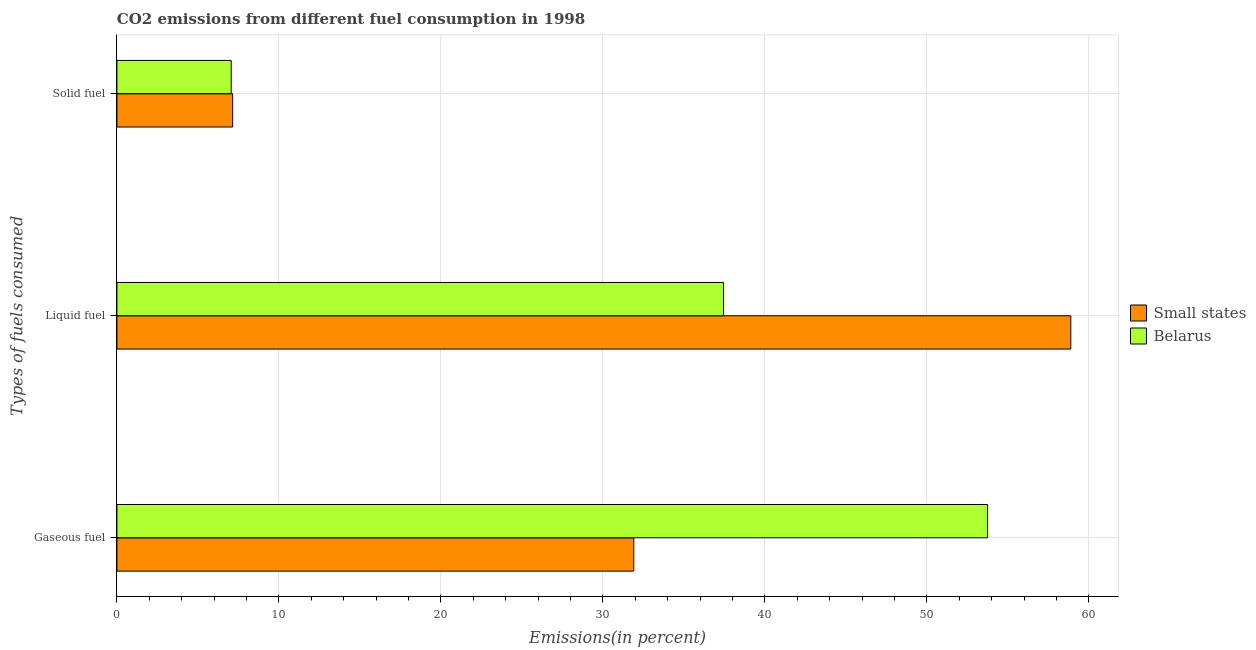Are the number of bars per tick equal to the number of legend labels?
Offer a terse response. Yes. How many bars are there on the 2nd tick from the top?
Your answer should be compact. 2. What is the label of the 3rd group of bars from the top?
Offer a terse response. Gaseous fuel. What is the percentage of solid fuel emission in Small states?
Ensure brevity in your answer.  7.14. Across all countries, what is the maximum percentage of solid fuel emission?
Offer a very short reply. 7.14. Across all countries, what is the minimum percentage of gaseous fuel emission?
Provide a short and direct response. 31.9. In which country was the percentage of liquid fuel emission maximum?
Your response must be concise. Small states. In which country was the percentage of gaseous fuel emission minimum?
Give a very brief answer. Small states. What is the total percentage of solid fuel emission in the graph?
Offer a very short reply. 14.2. What is the difference between the percentage of solid fuel emission in Small states and that in Belarus?
Your response must be concise. 0.09. What is the difference between the percentage of liquid fuel emission in Small states and the percentage of solid fuel emission in Belarus?
Your answer should be very brief. 51.82. What is the average percentage of gaseous fuel emission per country?
Provide a succinct answer. 42.82. What is the difference between the percentage of solid fuel emission and percentage of gaseous fuel emission in Small states?
Make the answer very short. -24.76. What is the ratio of the percentage of liquid fuel emission in Small states to that in Belarus?
Keep it short and to the point. 1.57. Is the difference between the percentage of liquid fuel emission in Belarus and Small states greater than the difference between the percentage of solid fuel emission in Belarus and Small states?
Offer a terse response. No. What is the difference between the highest and the second highest percentage of gaseous fuel emission?
Your answer should be compact. 21.84. What is the difference between the highest and the lowest percentage of liquid fuel emission?
Your answer should be very brief. 21.44. Is the sum of the percentage of liquid fuel emission in Belarus and Small states greater than the maximum percentage of gaseous fuel emission across all countries?
Provide a succinct answer. Yes. What does the 2nd bar from the top in Liquid fuel represents?
Give a very brief answer. Small states. What does the 2nd bar from the bottom in Gaseous fuel represents?
Offer a very short reply. Belarus. Are all the bars in the graph horizontal?
Your answer should be very brief. Yes. How many countries are there in the graph?
Your answer should be compact. 2. What is the difference between two consecutive major ticks on the X-axis?
Your answer should be very brief. 10. Are the values on the major ticks of X-axis written in scientific E-notation?
Ensure brevity in your answer.  No. Does the graph contain any zero values?
Your answer should be very brief. No. Does the graph contain grids?
Make the answer very short. Yes. How many legend labels are there?
Offer a very short reply. 2. What is the title of the graph?
Give a very brief answer. CO2 emissions from different fuel consumption in 1998. Does "United Arab Emirates" appear as one of the legend labels in the graph?
Your response must be concise. No. What is the label or title of the X-axis?
Provide a short and direct response. Emissions(in percent). What is the label or title of the Y-axis?
Provide a short and direct response. Types of fuels consumed. What is the Emissions(in percent) in Small states in Gaseous fuel?
Provide a succinct answer. 31.9. What is the Emissions(in percent) of Belarus in Gaseous fuel?
Provide a short and direct response. 53.74. What is the Emissions(in percent) in Small states in Liquid fuel?
Ensure brevity in your answer.  58.88. What is the Emissions(in percent) in Belarus in Liquid fuel?
Your response must be concise. 37.44. What is the Emissions(in percent) of Small states in Solid fuel?
Give a very brief answer. 7.14. What is the Emissions(in percent) in Belarus in Solid fuel?
Offer a terse response. 7.05. Across all Types of fuels consumed, what is the maximum Emissions(in percent) of Small states?
Your answer should be very brief. 58.88. Across all Types of fuels consumed, what is the maximum Emissions(in percent) of Belarus?
Provide a short and direct response. 53.74. Across all Types of fuels consumed, what is the minimum Emissions(in percent) of Small states?
Your answer should be very brief. 7.14. Across all Types of fuels consumed, what is the minimum Emissions(in percent) of Belarus?
Your answer should be very brief. 7.05. What is the total Emissions(in percent) in Small states in the graph?
Your answer should be very brief. 97.93. What is the total Emissions(in percent) of Belarus in the graph?
Provide a short and direct response. 98.24. What is the difference between the Emissions(in percent) of Small states in Gaseous fuel and that in Liquid fuel?
Ensure brevity in your answer.  -26.97. What is the difference between the Emissions(in percent) in Belarus in Gaseous fuel and that in Liquid fuel?
Make the answer very short. 16.3. What is the difference between the Emissions(in percent) of Small states in Gaseous fuel and that in Solid fuel?
Offer a terse response. 24.76. What is the difference between the Emissions(in percent) of Belarus in Gaseous fuel and that in Solid fuel?
Offer a terse response. 46.69. What is the difference between the Emissions(in percent) in Small states in Liquid fuel and that in Solid fuel?
Give a very brief answer. 51.73. What is the difference between the Emissions(in percent) of Belarus in Liquid fuel and that in Solid fuel?
Your answer should be compact. 30.39. What is the difference between the Emissions(in percent) of Small states in Gaseous fuel and the Emissions(in percent) of Belarus in Liquid fuel?
Your response must be concise. -5.54. What is the difference between the Emissions(in percent) in Small states in Gaseous fuel and the Emissions(in percent) in Belarus in Solid fuel?
Your answer should be very brief. 24.85. What is the difference between the Emissions(in percent) of Small states in Liquid fuel and the Emissions(in percent) of Belarus in Solid fuel?
Keep it short and to the point. 51.82. What is the average Emissions(in percent) of Small states per Types of fuels consumed?
Offer a very short reply. 32.64. What is the average Emissions(in percent) in Belarus per Types of fuels consumed?
Make the answer very short. 32.75. What is the difference between the Emissions(in percent) of Small states and Emissions(in percent) of Belarus in Gaseous fuel?
Your response must be concise. -21.84. What is the difference between the Emissions(in percent) of Small states and Emissions(in percent) of Belarus in Liquid fuel?
Provide a short and direct response. 21.44. What is the difference between the Emissions(in percent) in Small states and Emissions(in percent) in Belarus in Solid fuel?
Offer a very short reply. 0.09. What is the ratio of the Emissions(in percent) of Small states in Gaseous fuel to that in Liquid fuel?
Your answer should be very brief. 0.54. What is the ratio of the Emissions(in percent) of Belarus in Gaseous fuel to that in Liquid fuel?
Your response must be concise. 1.44. What is the ratio of the Emissions(in percent) of Small states in Gaseous fuel to that in Solid fuel?
Provide a succinct answer. 4.47. What is the ratio of the Emissions(in percent) in Belarus in Gaseous fuel to that in Solid fuel?
Give a very brief answer. 7.62. What is the ratio of the Emissions(in percent) in Small states in Liquid fuel to that in Solid fuel?
Make the answer very short. 8.24. What is the ratio of the Emissions(in percent) of Belarus in Liquid fuel to that in Solid fuel?
Provide a succinct answer. 5.31. What is the difference between the highest and the second highest Emissions(in percent) in Small states?
Your answer should be compact. 26.97. What is the difference between the highest and the second highest Emissions(in percent) of Belarus?
Your response must be concise. 16.3. What is the difference between the highest and the lowest Emissions(in percent) in Small states?
Provide a short and direct response. 51.73. What is the difference between the highest and the lowest Emissions(in percent) of Belarus?
Your response must be concise. 46.69. 